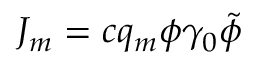<formula> <loc_0><loc_0><loc_500><loc_500>J _ { m } = c q _ { m } \phi \gamma _ { 0 } \tilde { \phi } \,</formula> 